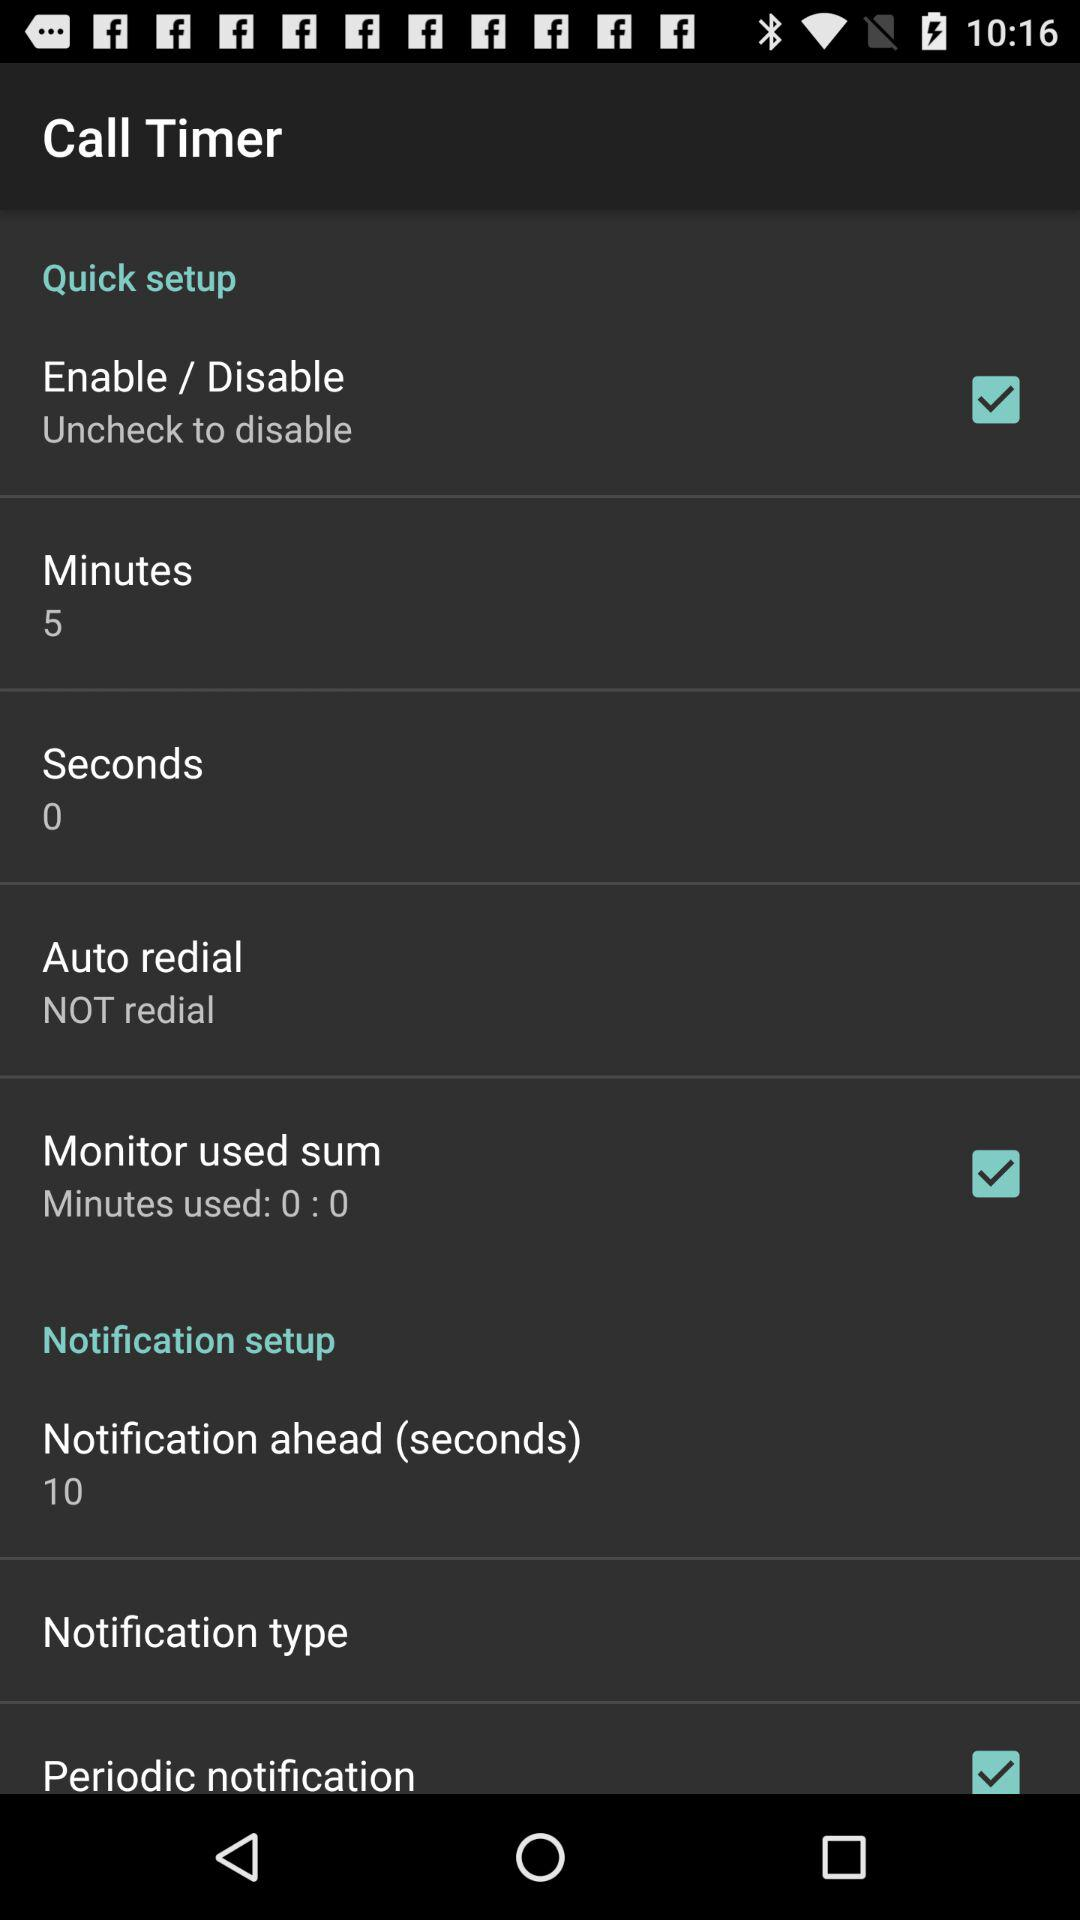How many minutes are shown there? There are 5 minutes shown. 